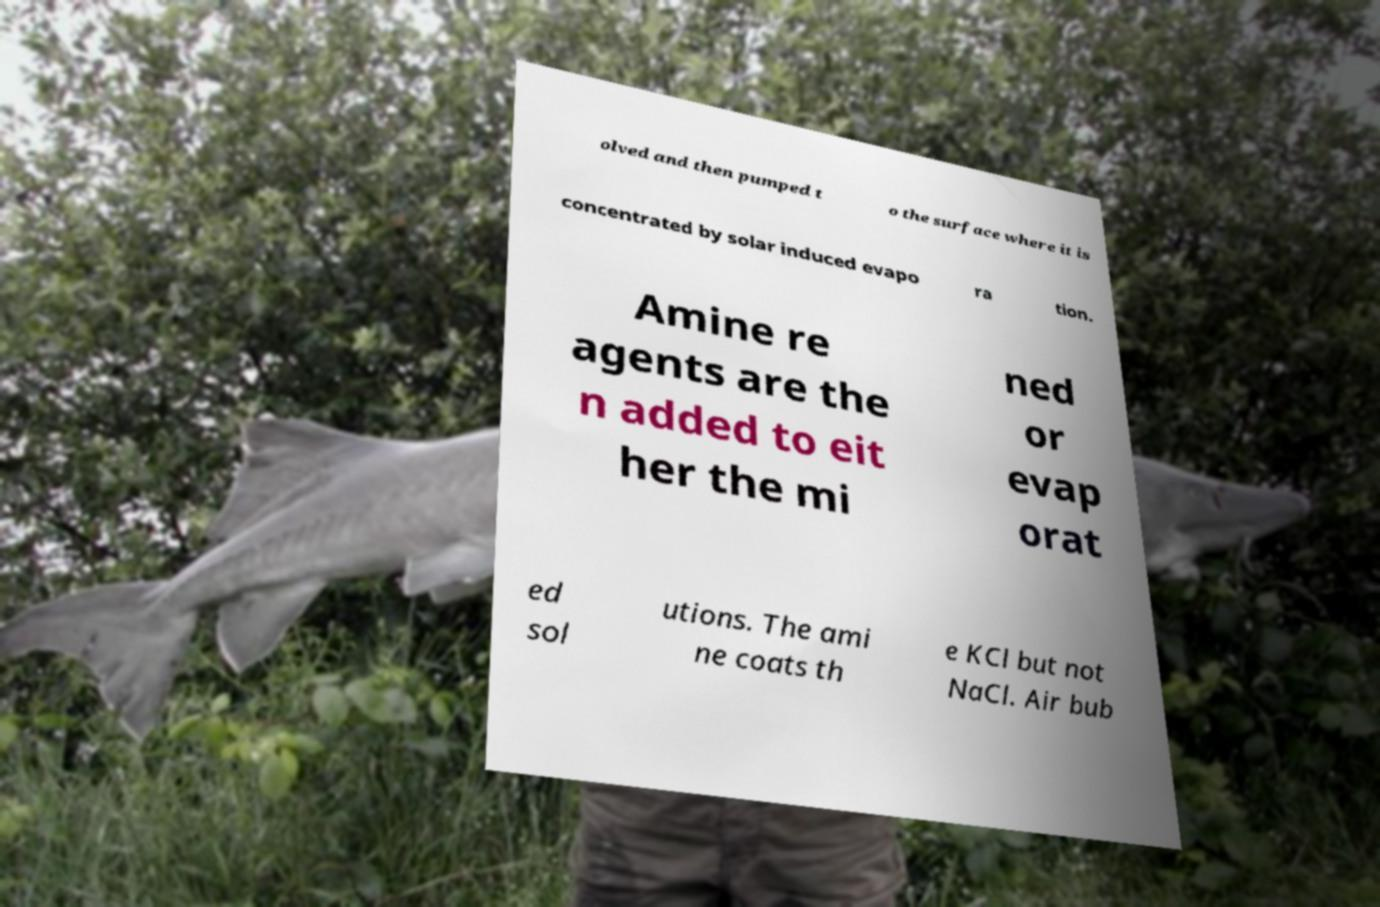Could you assist in decoding the text presented in this image and type it out clearly? olved and then pumped t o the surface where it is concentrated by solar induced evapo ra tion. Amine re agents are the n added to eit her the mi ned or evap orat ed sol utions. The ami ne coats th e KCl but not NaCl. Air bub 